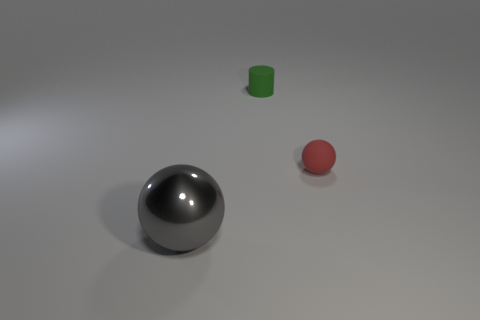What is the material of the other small red object that is the same shape as the shiny thing?
Make the answer very short. Rubber. Are there any other cylinders that have the same size as the green cylinder?
Your answer should be very brief. No. What size is the object on the left side of the small object that is on the left side of the ball behind the big thing?
Your response must be concise. Large. The rubber sphere has what color?
Give a very brief answer. Red. Are there more matte cylinders to the right of the metallic sphere than small red metal spheres?
Provide a succinct answer. Yes. What number of rubber spheres are behind the green cylinder?
Provide a succinct answer. 0. There is a rubber object on the left side of the sphere behind the large gray metal sphere; is there a tiny red matte object that is on the right side of it?
Offer a terse response. Yes. Does the green cylinder have the same size as the red matte thing?
Offer a very short reply. Yes. Is the number of red rubber spheres that are right of the green matte cylinder the same as the number of green rubber things behind the small ball?
Keep it short and to the point. Yes. There is a thing in front of the small red rubber thing; what is its shape?
Your answer should be very brief. Sphere. 